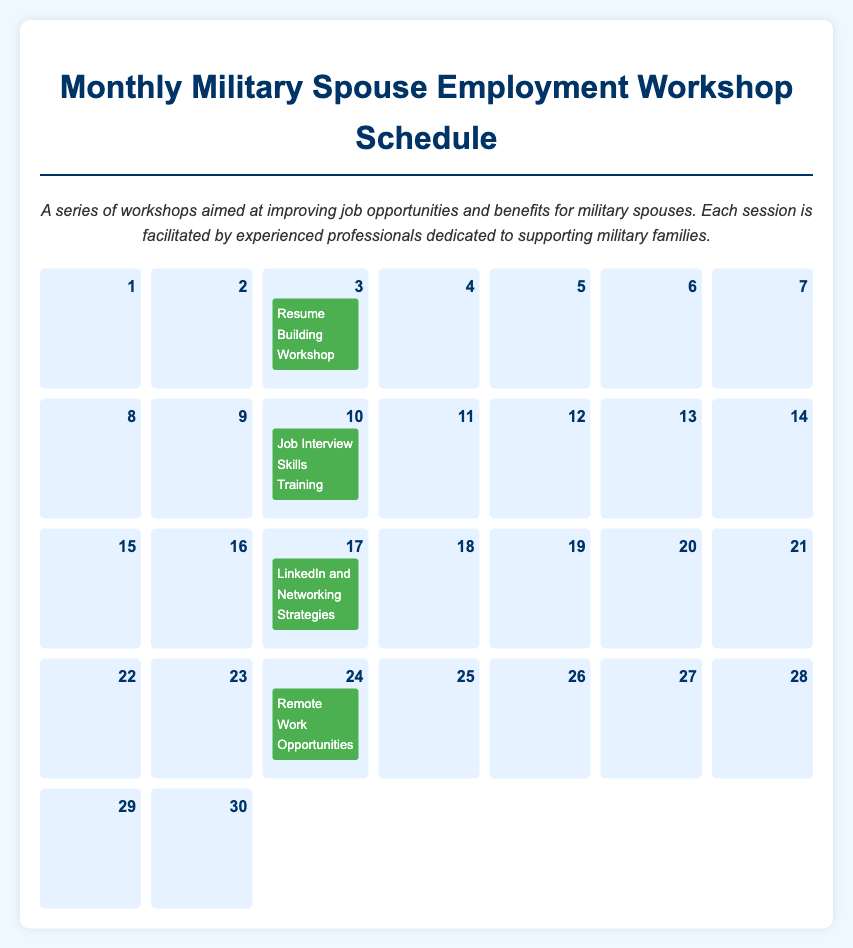What is the title of the first workshop in the calendar? The title of the workshop is mentioned in the event on the 3rd of the month, which is "Resume Building Workshop."
Answer: Resume Building Workshop Who is the facilitator for the Job Interview Skills Training? The facilitator's name is indicated in the event details for the Job Interview Skills Training on the 10th, which is "Jane Doe."
Answer: Jane Doe What time does the LinkedIn and Networking Strategies session start? The starting time for this session is listed in the event details for the 17th, which is "9:00 AM."
Answer: 9:00 AM How many workshops are scheduled in total? The total number of workshops can be counted from the events listed; there are events on the 3rd, 10th, 17th, and 24th, totaling four workshops.
Answer: 4 What is one topic covered in the Remote Work Opportunities workshop? One topic is described in the event details for the 24th, which is exploring "various remote work options."
Answer: Various remote work options What is the color of the event boxes on the calendar? The color used for the event boxes is described in the style section of the document, which is "green."
Answer: Green 